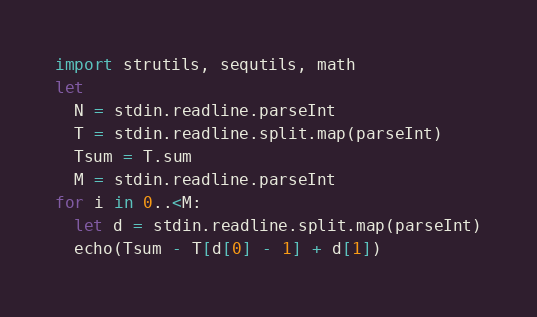Convert code to text. <code><loc_0><loc_0><loc_500><loc_500><_Nim_>import strutils, sequtils, math
let
  N = stdin.readline.parseInt
  T = stdin.readline.split.map(parseInt)
  Tsum = T.sum
  M = stdin.readline.parseInt
for i in 0..<M:
  let d = stdin.readline.split.map(parseInt)
  echo(Tsum - T[d[0] - 1] + d[1])
</code> 